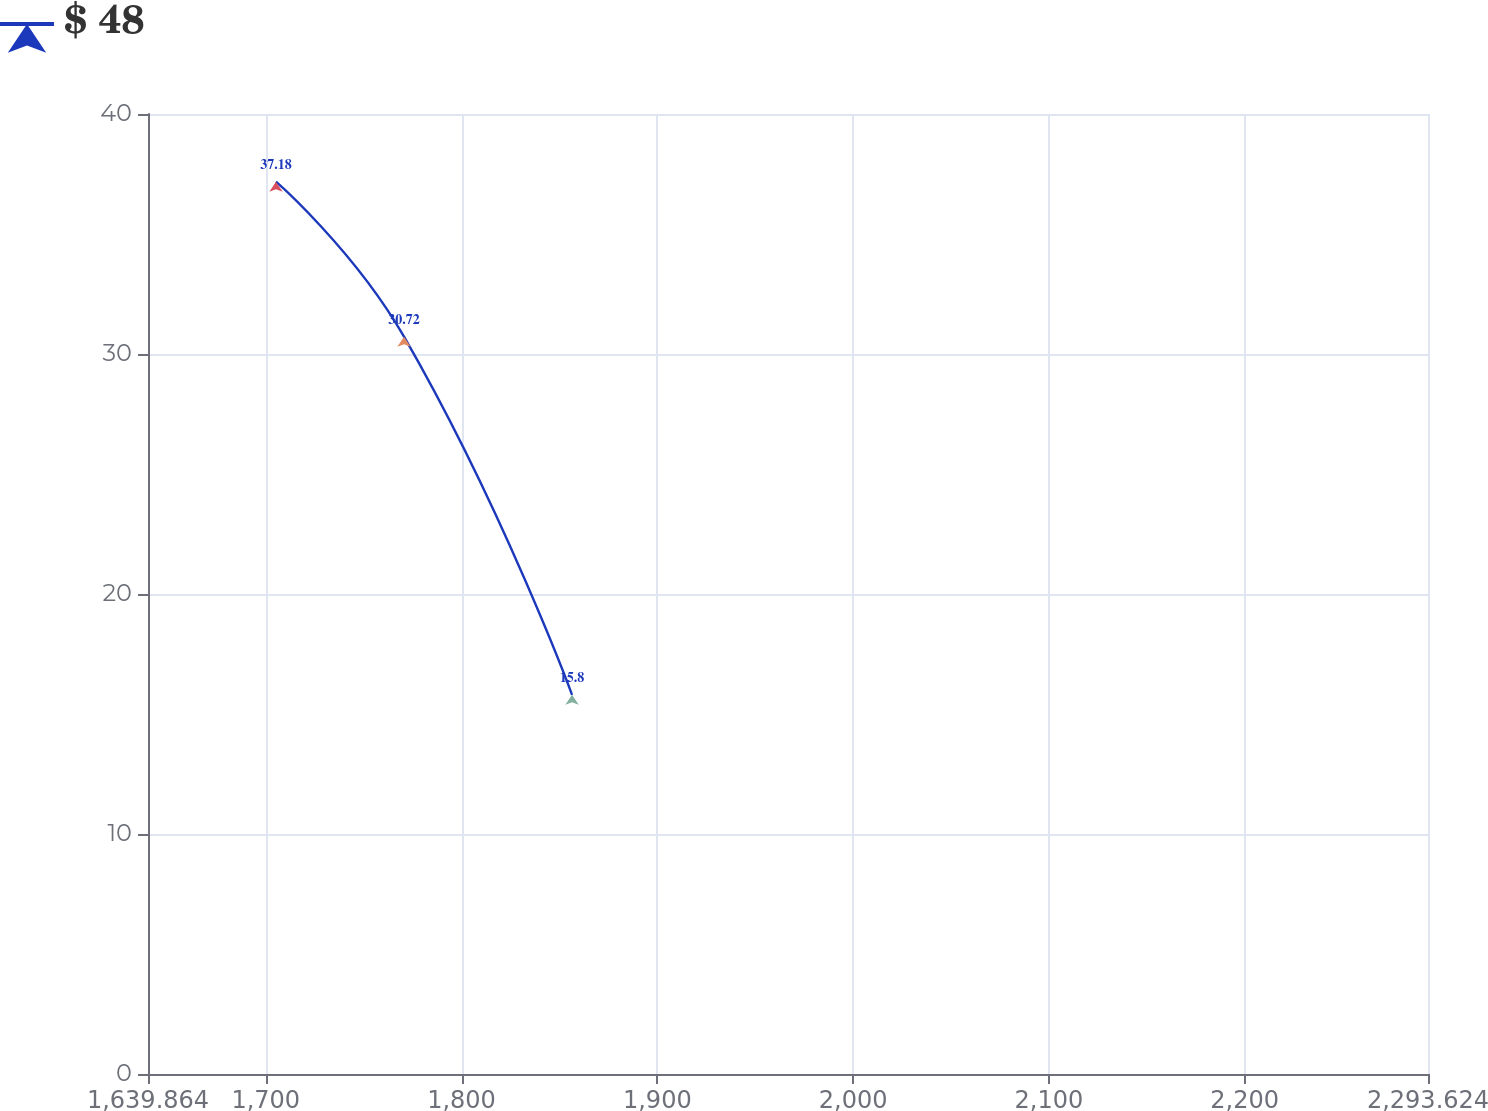Convert chart. <chart><loc_0><loc_0><loc_500><loc_500><line_chart><ecel><fcel>$ 48<nl><fcel>1705.24<fcel>37.18<nl><fcel>1770.62<fcel>30.72<nl><fcel>1856.45<fcel>15.8<nl><fcel>2359<fcel>11.67<nl></chart> 